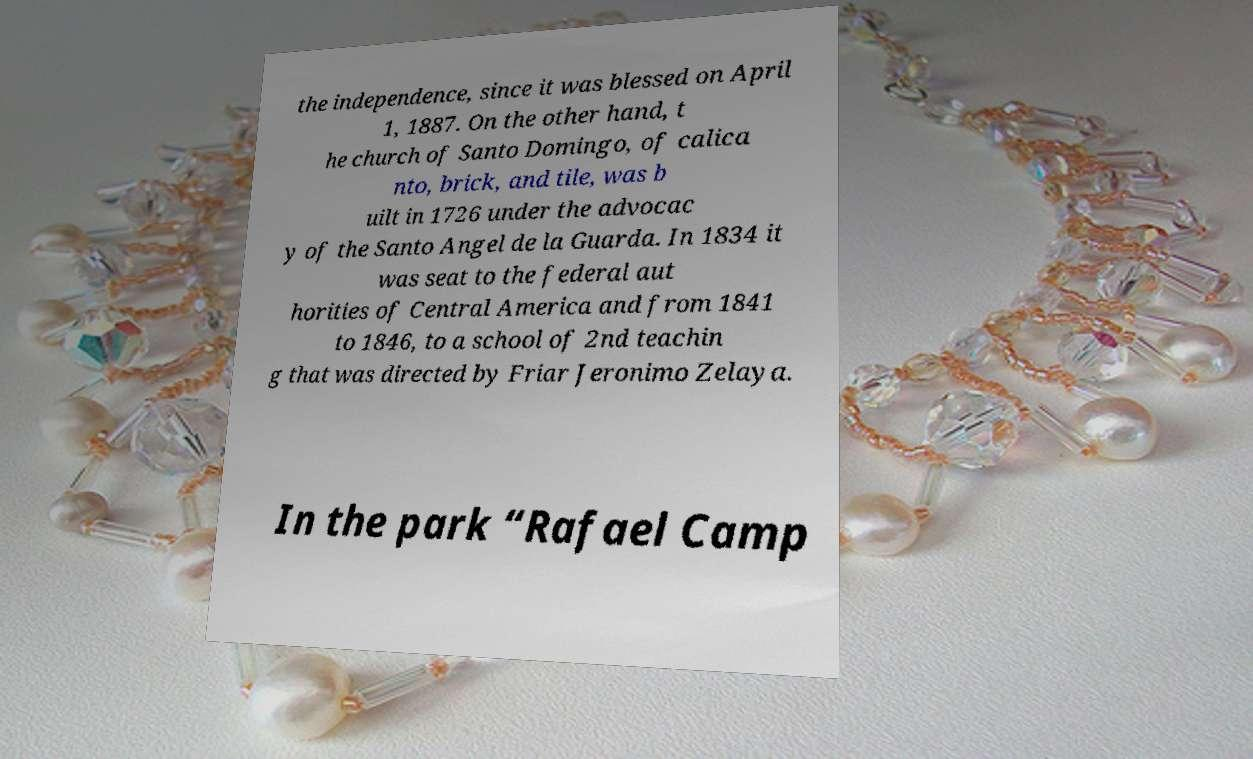Please read and relay the text visible in this image. What does it say? the independence, since it was blessed on April 1, 1887. On the other hand, t he church of Santo Domingo, of calica nto, brick, and tile, was b uilt in 1726 under the advocac y of the Santo Angel de la Guarda. In 1834 it was seat to the federal aut horities of Central America and from 1841 to 1846, to a school of 2nd teachin g that was directed by Friar Jeronimo Zelaya. In the park “Rafael Camp 